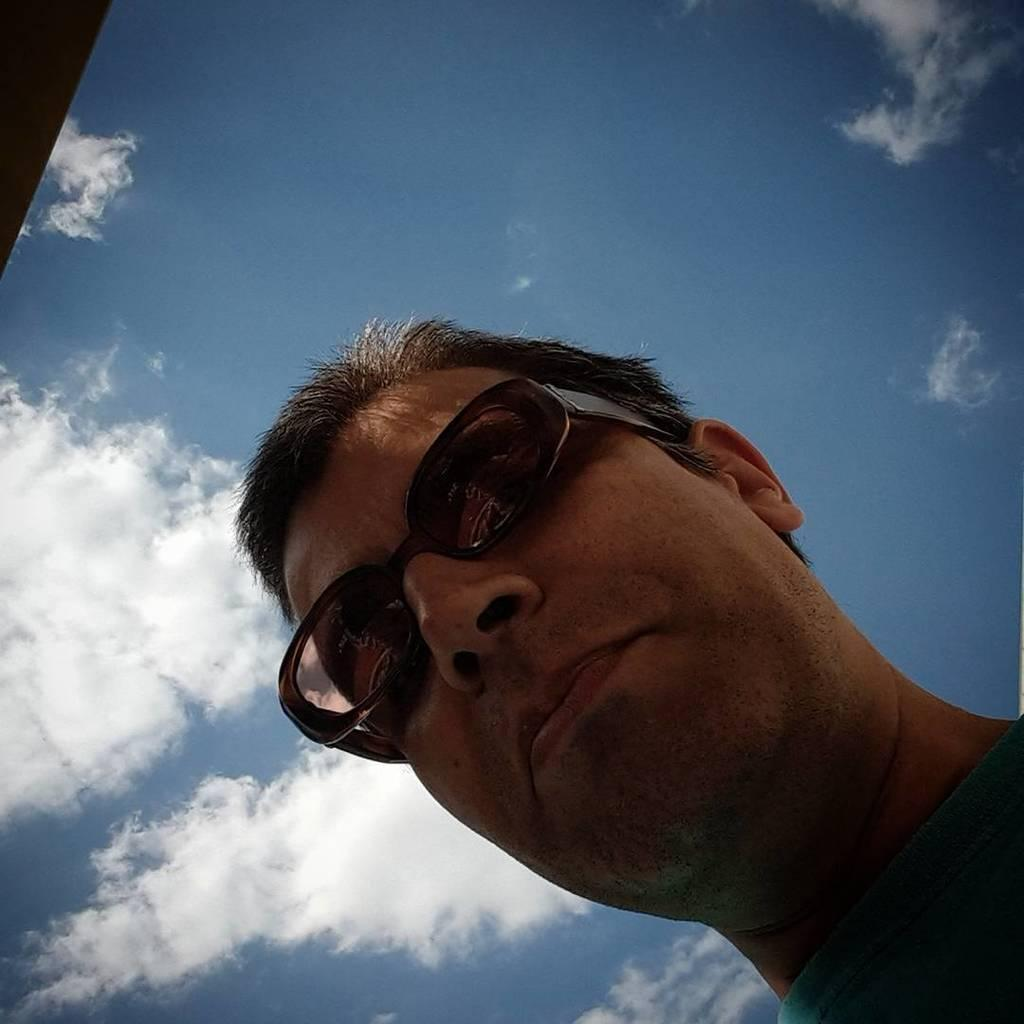What is the main subject in the foreground of the image? There is a man's face in the foreground of the image. What can be seen in the background of the image? The sky is visible in the image. What is the condition of the sky in the image? Clouds are present in the sky. What type of grass is growing on the man's face in the image? There is no grass present on the man's face in the image. 